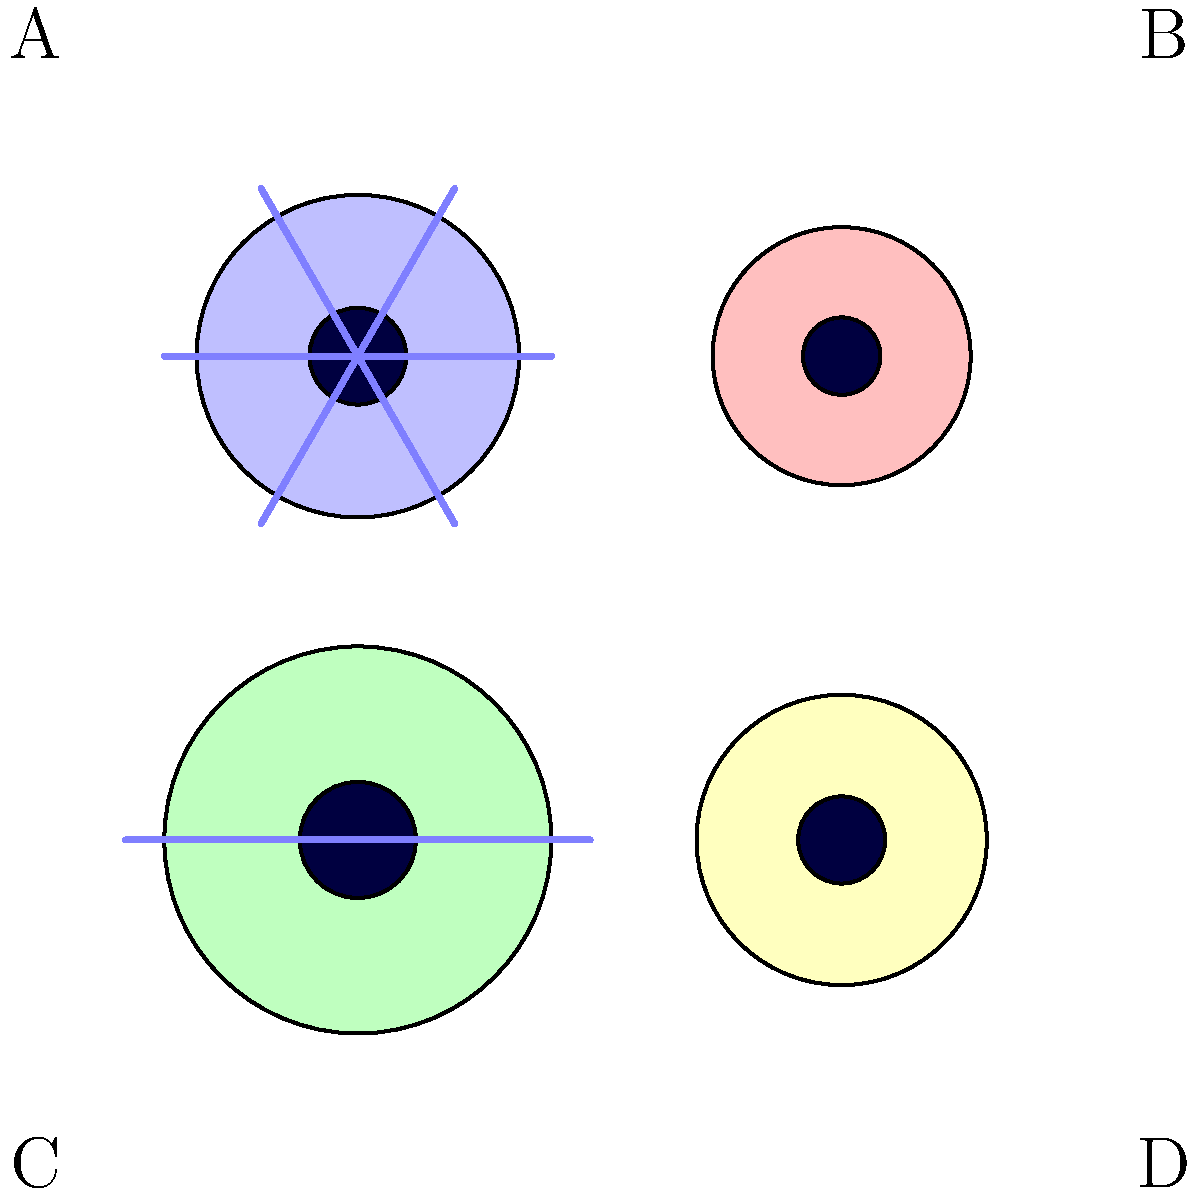Based on the microscope images of different probiotic bacteria, which one is most likely to be Lactobacillus acidophilus, a common probiotic known for its ability to adhere to the intestinal lining and support digestive health? To identify Lactobacillus acidophilus from the given microscope images, we need to consider its key characteristics:

1. Lactobacillus acidophilus is a rod-shaped bacterium.
2. It does not have flagella (hair-like structures used for movement).
3. It is typically smaller than many other probiotic bacteria.

Let's analyze each image:

A: This bacterium has multiple flagella and is relatively large. It's not Lactobacillus acidophilus.

B: This is a small, rod-shaped bacterium without flagella. These characteristics match Lactobacillus acidophilus.

C: This bacterium is large and has two flagella, which doesn't match the characteristics of Lactobacillus acidophilus.

D: While this bacterium is rod-shaped and lacks flagella, it appears larger than the bacterium in image B, making it less likely to be Lactobacillus acidophilus.

Based on these observations, image B most closely resembles the characteristics of Lactobacillus acidophilus.
Answer: B 